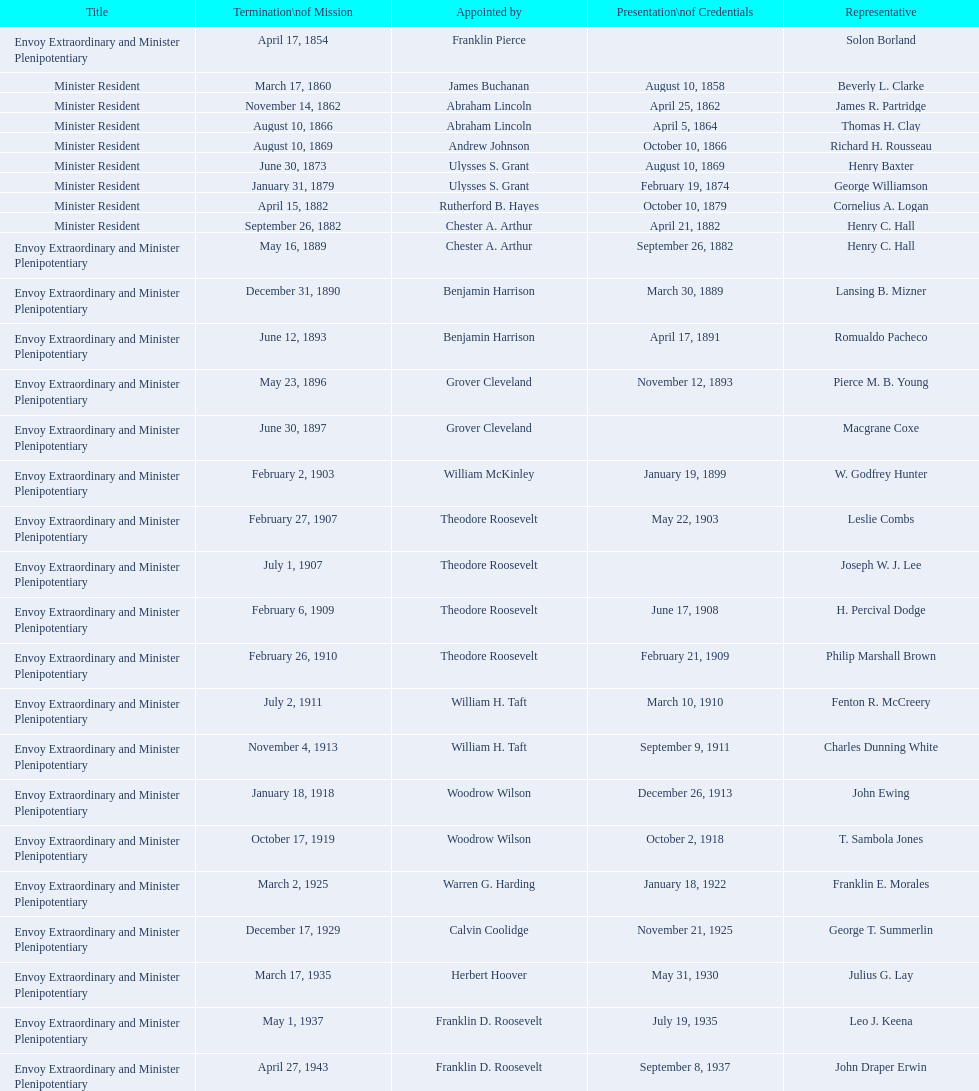Who was the last representative picked? Lisa Kubiske. 